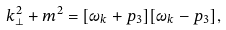Convert formula to latex. <formula><loc_0><loc_0><loc_500><loc_500>k ^ { 2 } _ { \perp } + m ^ { 2 } = [ \omega _ { k } + p _ { 3 } ] [ \omega _ { k } - p _ { 3 } ] ,</formula> 